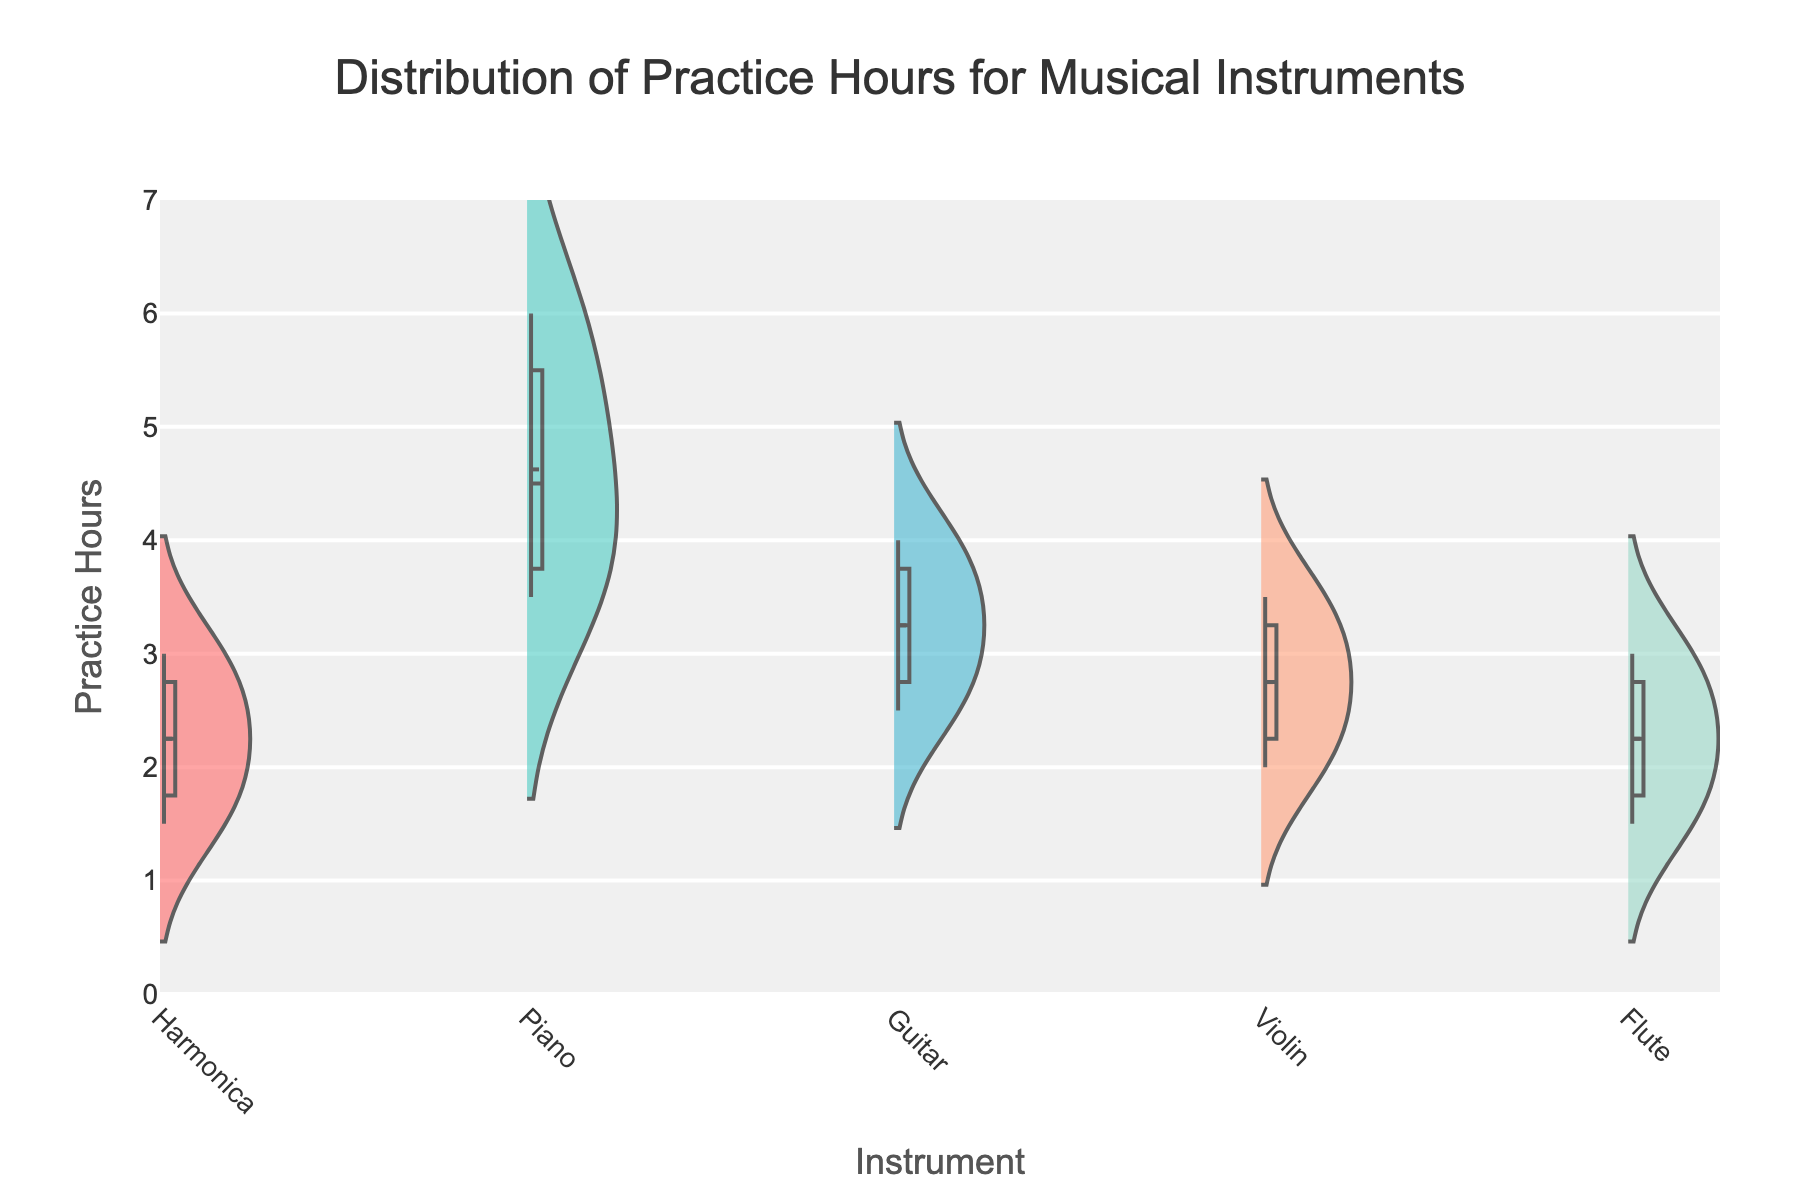What is the title of the figure? The title appears at the top of the figure giving an overview of what the plot is about. It is "Distribution of Practice Hours for Musical Instruments."
Answer: Distribution of Practice Hours for Musical Instruments Which instrument has the highest median practice hours? The median line on the violins indicates the center of the distribution for each instrument. The Piano has the highest median practice hours compared to the Harmonica, Guitar, Violin, and Flute.
Answer: Piano What is the y-axis range of the figure? The y-axis displays the range of practice hours and is set to go from 0 to 7 hours. This range is consistent for all instruments.
Answer: 0 to 7 Which instrument has data points with the widest range of practice hours? By observing the width between the top and bottom of their distributions, the Piano shows the widest range of practice hours, going from around 3.5 to 6 hours.
Answer: Piano How many unique instruments are represented in the figure? The unique instruments can be identified by the different traces. The instruments are Harmonica, Piano, Guitar, Violin, and Flute, making a total of 5 unique instruments.
Answer: 5 Which instrument has the lowest mean practice hours? By observing where the mean line is marked on each violin plot, the Harmonica shows the lowest mean practice hours compared to other instruments.
Answer: Harmonica How does the interquartile range (IQR) of Guitar practice hours compare to Flute practice hours? The IQR is the difference between the first quartile (Q1) and the third quartile (Q3). For the Guitar, the box shows Q1 around 2.5 and Q3 around 4. For the Flute, Q1 is around 1.5 and Q3 around 2.5. Therefore, the Guitar has a wider IQR.
Answer: Guitar has a wider IQR Which two instruments have the most similar distributions of practice hours? By comparing the distributions visually, the Harmonica and Violin have the most similar distributions in terms of range and shape.
Answer: Harmonica and Violin What is the practice hour range for the Flute? The range is determined by the minimum and maximum points in the Flute's distribution. The Flute's practice hours range from around 1.5 to 3 hours.
Answer: 1.5 to 3 hours Which instrument has the smallest difference between the highest and lowest practice hours? By observing the differences in the range of each instrument, the Harmonica practice hours range from 1.5 to 3 hours, which is the smallest range compared to other instruments.
Answer: Harmonica 